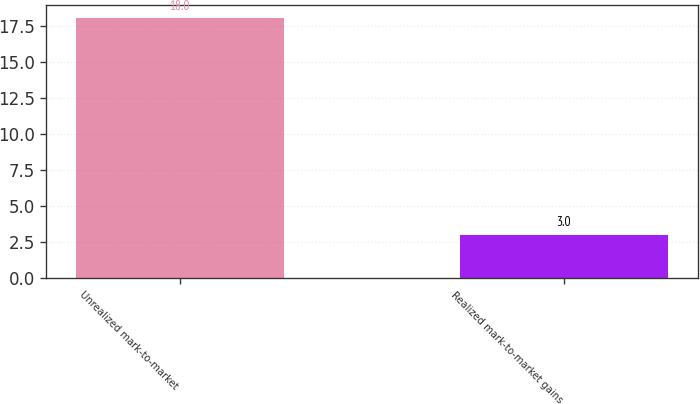Convert chart. <chart><loc_0><loc_0><loc_500><loc_500><bar_chart><fcel>Unrealized mark-to-market<fcel>Realized mark-to-market gains<nl><fcel>18<fcel>3<nl></chart> 